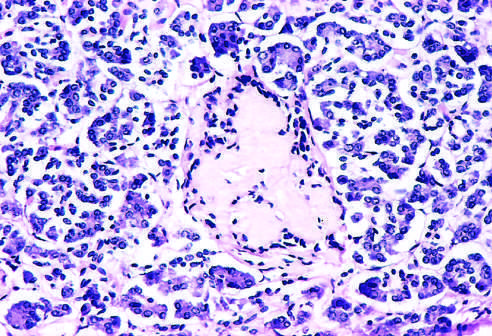what is observed late in the natural history of this form of diabetes, with islet inflammation noted at earlier observations?
Answer the question using a single word or phrase. Amyloidosis 